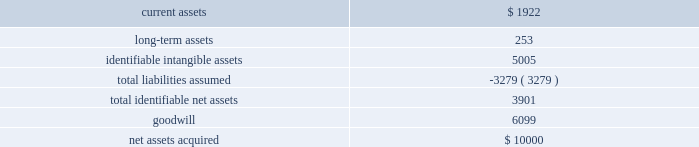58 2016 annual report note 12 .
Business acquisition bayside business solutions , inc .
Effective july 1 , 2015 , the company acquired all of the equity interests of bayside business solutions , an alabama-based company that provides technology solutions and payment processing services primarily for the financial services industry , for $ 10000 paid in cash .
This acquisition was funded using existing operating cash .
The acquisition of bayside business solutions expanded the company 2019s presence in commercial lending within the industry .
Management has completed a purchase price allocation of bayside business solutions and its assessment of the fair value of acquired assets and liabilities assumed .
The recognized amounts of identifiable assets acquired and liabilities assumed , based upon their fair values as of july 1 , 2015 are set forth below: .
The goodwill of $ 6099 arising from this acquisition consists largely of the growth potential , synergies and economies of scale expected from combining the operations of the company with those of bayside business solutions , together with the value of bayside business solutions 2019 assembled workforce .
Goodwill from this acquisition has been allocated to our banking systems and services segment .
The goodwill is not expected to be deductible for income tax purposes .
Identifiable intangible assets from this acquisition consist of customer relationships of $ 3402 , $ 659 of computer software and other intangible assets of $ 944 .
The weighted average amortization period for acquired customer relationships , acquired computer software , and other intangible assets is 15 years , 5 years , and 20 years , respectively .
Current assets were inclusive of cash acquired of $ 1725 .
The fair value of current assets acquired included accounts receivable of $ 178 .
The gross amount of receivables was $ 178 , none of which was expected to be uncollectible .
During fiscal year 2016 , the company incurred $ 55 in costs related to the acquisition of bayside business solutions .
These costs included fees for legal , valuation and other fees .
These costs were included within general and administrative expenses .
The results of bayside business solutions 2019 operations included in the company 2019s consolidated statement of income for the twelve months ended june 30 , 2016 included revenue of $ 4273 and after-tax net income of $ 303 .
The accompanying consolidated statements of income for the fiscal year ended june 30 , 2016 do not include any revenues and expenses related to this acquisition prior to the acquisition date .
The impact of this acquisition was considered immaterial to both the current and prior periods of our consolidated financial statements and pro forma financial information has not been provided .
Banno , llc effective march 1 , 2014 , the company acquired all of the equity interests of banno , an iowa-based company that provides web and transaction marketing services with a focus on the mobile medium , for $ 27910 paid in cash .
This acquisition was funded using existing operating cash .
The acquisition of banno expanded the company 2019s presence in online and mobile technologies within the industry .
During fiscal year 2014 , the company incurred $ 30 in costs related to the acquisition of banno .
These costs included fees for legal , valuation and other fees .
These costs were included within general and administrative expenses .
The results of banno's operations included in the company's consolidated statements of income for the year ended june 30 , 2016 included revenue of $ 6393 and after-tax net loss of $ 1289 .
For the year ended june 30 , 2015 , our consolidated statements of income included revenue of $ 4175 and after-tax net loss of $ 1784 attributable to banno .
The results of banno 2019s operations included in the company 2019s consolidated statement of operations from the acquisition date to june 30 , 2014 included revenue of $ 848 and after-tax net loss of $ 1121 .
The accompanying consolidated statements of income for the twelve month period ended june 30 , 2016 do not include any revenues and expenses related to this acquisition prior to the acquisition date .
The impact of this acquisition was considered immaterial to both the current and prior periods of our consolidated financial statements and pro forma financial information has not been provided. .
Were current assets acquired greater than long-term assets? 
Computations: (1922 > 253)
Answer: yes. 58 2016 annual report note 12 .
Business acquisition bayside business solutions , inc .
Effective july 1 , 2015 , the company acquired all of the equity interests of bayside business solutions , an alabama-based company that provides technology solutions and payment processing services primarily for the financial services industry , for $ 10000 paid in cash .
This acquisition was funded using existing operating cash .
The acquisition of bayside business solutions expanded the company 2019s presence in commercial lending within the industry .
Management has completed a purchase price allocation of bayside business solutions and its assessment of the fair value of acquired assets and liabilities assumed .
The recognized amounts of identifiable assets acquired and liabilities assumed , based upon their fair values as of july 1 , 2015 are set forth below: .
The goodwill of $ 6099 arising from this acquisition consists largely of the growth potential , synergies and economies of scale expected from combining the operations of the company with those of bayside business solutions , together with the value of bayside business solutions 2019 assembled workforce .
Goodwill from this acquisition has been allocated to our banking systems and services segment .
The goodwill is not expected to be deductible for income tax purposes .
Identifiable intangible assets from this acquisition consist of customer relationships of $ 3402 , $ 659 of computer software and other intangible assets of $ 944 .
The weighted average amortization period for acquired customer relationships , acquired computer software , and other intangible assets is 15 years , 5 years , and 20 years , respectively .
Current assets were inclusive of cash acquired of $ 1725 .
The fair value of current assets acquired included accounts receivable of $ 178 .
The gross amount of receivables was $ 178 , none of which was expected to be uncollectible .
During fiscal year 2016 , the company incurred $ 55 in costs related to the acquisition of bayside business solutions .
These costs included fees for legal , valuation and other fees .
These costs were included within general and administrative expenses .
The results of bayside business solutions 2019 operations included in the company 2019s consolidated statement of income for the twelve months ended june 30 , 2016 included revenue of $ 4273 and after-tax net income of $ 303 .
The accompanying consolidated statements of income for the fiscal year ended june 30 , 2016 do not include any revenues and expenses related to this acquisition prior to the acquisition date .
The impact of this acquisition was considered immaterial to both the current and prior periods of our consolidated financial statements and pro forma financial information has not been provided .
Banno , llc effective march 1 , 2014 , the company acquired all of the equity interests of banno , an iowa-based company that provides web and transaction marketing services with a focus on the mobile medium , for $ 27910 paid in cash .
This acquisition was funded using existing operating cash .
The acquisition of banno expanded the company 2019s presence in online and mobile technologies within the industry .
During fiscal year 2014 , the company incurred $ 30 in costs related to the acquisition of banno .
These costs included fees for legal , valuation and other fees .
These costs were included within general and administrative expenses .
The results of banno's operations included in the company's consolidated statements of income for the year ended june 30 , 2016 included revenue of $ 6393 and after-tax net loss of $ 1289 .
For the year ended june 30 , 2015 , our consolidated statements of income included revenue of $ 4175 and after-tax net loss of $ 1784 attributable to banno .
The results of banno 2019s operations included in the company 2019s consolidated statement of operations from the acquisition date to june 30 , 2014 included revenue of $ 848 and after-tax net loss of $ 1121 .
The accompanying consolidated statements of income for the twelve month period ended june 30 , 2016 do not include any revenues and expenses related to this acquisition prior to the acquisition date .
The impact of this acquisition was considered immaterial to both the current and prior periods of our consolidated financial statements and pro forma financial information has not been provided. .
What was the average revenue generated by banno between 2014 and 2016? 
Computations: (848 + (6393 + 4175))
Answer: 11416.0. 59jackhenry.com note 12 .
Business acquisition bayside business solutions , inc .
Effective july 1 , 2015 , the company acquired all of the equity interests of bayside business solutions , an alabama-based company that provides technology solutions and payment processing services primarily for the financial services industry , for $ 10000 paid in cash .
This acquisition was funded using existing operating cash .
The acquisition of bayside business solutions expanded the company 2019s presence in commercial lending within the industry .
Management has completed a purchase price allocation of bayside business solutions and its assessment of the fair value of acquired assets and liabilities assumed .
The recognized amounts of identifiable assets acquired and liabilities assumed , based upon their fair values as of july 1 , 2015 are set forth below: .
The goodwill of $ 6099 arising from this acquisition consists largely of the growth potential , synergies and economies of scale expected from combining the operations of the company with those of bayside business solutions , together with the value of bayside business solutions 2019 assembled workforce .
Goodwill from this acquisition has been allocated to our bank systems and services segment .
The goodwill is not expected to be deductible for income tax purposes .
Identifiable intangible assets from this acquisition consist of customer relationships of $ 3402 , $ 659 of computer software and other intangible assets of $ 944 .
The weighted average amortization period for acquired customer relationships , acquired computer software , and other intangible assets is 15 years , 5 years , and 20 years , respectively .
Current assets were inclusive of cash acquired of $ 1725 .
The fair value of current assets acquired included accounts receivable of $ 178 .
The gross amount of receivables was $ 178 , none of which was expected to be uncollectible .
During fiscal year 2016 , the company incurred $ 55 in costs related to the acquisition of bayside business solutions .
These costs included fees for legal , valuation and other fees .
These costs were included within general and administrative expenses .
The results of bayside business solutions 2019 operations included in the company 2019s consolidated statement of income for the twelve months ended june 30 , 2017 included revenue of $ 6536 and after-tax net income of $ 1307 .
For the twelve months ended june 30 , 2016 , bayside business solutions 2019 contributed $ 4273 to revenue , and after-tax net income of $ 303 .
The accompanying consolidated statements of income do not include any revenues and expenses related to this acquisition prior to the acquisition date .
The impact of this acquisition was considered immaterial to both the current and prior periods of our consolidated financial statements and pro forma financial information has not been provided. .
What was the percent of the total assets acquisitions allocated to goodwill? 
Computations: (6099 / 10000)
Answer: 0.6099. 58 2016 annual report note 12 .
Business acquisition bayside business solutions , inc .
Effective july 1 , 2015 , the company acquired all of the equity interests of bayside business solutions , an alabama-based company that provides technology solutions and payment processing services primarily for the financial services industry , for $ 10000 paid in cash .
This acquisition was funded using existing operating cash .
The acquisition of bayside business solutions expanded the company 2019s presence in commercial lending within the industry .
Management has completed a purchase price allocation of bayside business solutions and its assessment of the fair value of acquired assets and liabilities assumed .
The recognized amounts of identifiable assets acquired and liabilities assumed , based upon their fair values as of july 1 , 2015 are set forth below: .
The goodwill of $ 6099 arising from this acquisition consists largely of the growth potential , synergies and economies of scale expected from combining the operations of the company with those of bayside business solutions , together with the value of bayside business solutions 2019 assembled workforce .
Goodwill from this acquisition has been allocated to our banking systems and services segment .
The goodwill is not expected to be deductible for income tax purposes .
Identifiable intangible assets from this acquisition consist of customer relationships of $ 3402 , $ 659 of computer software and other intangible assets of $ 944 .
The weighted average amortization period for acquired customer relationships , acquired computer software , and other intangible assets is 15 years , 5 years , and 20 years , respectively .
Current assets were inclusive of cash acquired of $ 1725 .
The fair value of current assets acquired included accounts receivable of $ 178 .
The gross amount of receivables was $ 178 , none of which was expected to be uncollectible .
During fiscal year 2016 , the company incurred $ 55 in costs related to the acquisition of bayside business solutions .
These costs included fees for legal , valuation and other fees .
These costs were included within general and administrative expenses .
The results of bayside business solutions 2019 operations included in the company 2019s consolidated statement of income for the twelve months ended june 30 , 2016 included revenue of $ 4273 and after-tax net income of $ 303 .
The accompanying consolidated statements of income for the fiscal year ended june 30 , 2016 do not include any revenues and expenses related to this acquisition prior to the acquisition date .
The impact of this acquisition was considered immaterial to both the current and prior periods of our consolidated financial statements and pro forma financial information has not been provided .
Banno , llc effective march 1 , 2014 , the company acquired all of the equity interests of banno , an iowa-based company that provides web and transaction marketing services with a focus on the mobile medium , for $ 27910 paid in cash .
This acquisition was funded using existing operating cash .
The acquisition of banno expanded the company 2019s presence in online and mobile technologies within the industry .
During fiscal year 2014 , the company incurred $ 30 in costs related to the acquisition of banno .
These costs included fees for legal , valuation and other fees .
These costs were included within general and administrative expenses .
The results of banno's operations included in the company's consolidated statements of income for the year ended june 30 , 2016 included revenue of $ 6393 and after-tax net loss of $ 1289 .
For the year ended june 30 , 2015 , our consolidated statements of income included revenue of $ 4175 and after-tax net loss of $ 1784 attributable to banno .
The results of banno 2019s operations included in the company 2019s consolidated statement of operations from the acquisition date to june 30 , 2014 included revenue of $ 848 and after-tax net loss of $ 1121 .
The accompanying consolidated statements of income for the twelve month period ended june 30 , 2016 do not include any revenues and expenses related to this acquisition prior to the acquisition date .
The impact of this acquisition was considered immaterial to both the current and prior periods of our consolidated financial statements and pro forma financial information has not been provided. .
What was the percent of the ash in the current assets acquired? 
Computations: (1725 / 1922)
Answer: 0.8975. 59jackhenry.com note 12 .
Business acquisition bayside business solutions , inc .
Effective july 1 , 2015 , the company acquired all of the equity interests of bayside business solutions , an alabama-based company that provides technology solutions and payment processing services primarily for the financial services industry , for $ 10000 paid in cash .
This acquisition was funded using existing operating cash .
The acquisition of bayside business solutions expanded the company 2019s presence in commercial lending within the industry .
Management has completed a purchase price allocation of bayside business solutions and its assessment of the fair value of acquired assets and liabilities assumed .
The recognized amounts of identifiable assets acquired and liabilities assumed , based upon their fair values as of july 1 , 2015 are set forth below: .
The goodwill of $ 6099 arising from this acquisition consists largely of the growth potential , synergies and economies of scale expected from combining the operations of the company with those of bayside business solutions , together with the value of bayside business solutions 2019 assembled workforce .
Goodwill from this acquisition has been allocated to our bank systems and services segment .
The goodwill is not expected to be deductible for income tax purposes .
Identifiable intangible assets from this acquisition consist of customer relationships of $ 3402 , $ 659 of computer software and other intangible assets of $ 944 .
The weighted average amortization period for acquired customer relationships , acquired computer software , and other intangible assets is 15 years , 5 years , and 20 years , respectively .
Current assets were inclusive of cash acquired of $ 1725 .
The fair value of current assets acquired included accounts receivable of $ 178 .
The gross amount of receivables was $ 178 , none of which was expected to be uncollectible .
During fiscal year 2016 , the company incurred $ 55 in costs related to the acquisition of bayside business solutions .
These costs included fees for legal , valuation and other fees .
These costs were included within general and administrative expenses .
The results of bayside business solutions 2019 operations included in the company 2019s consolidated statement of income for the twelve months ended june 30 , 2017 included revenue of $ 6536 and after-tax net income of $ 1307 .
For the twelve months ended june 30 , 2016 , bayside business solutions 2019 contributed $ 4273 to revenue , and after-tax net income of $ 303 .
The accompanying consolidated statements of income do not include any revenues and expenses related to this acquisition prior to the acquisition date .
The impact of this acquisition was considered immaterial to both the current and prior periods of our consolidated financial statements and pro forma financial information has not been provided. .
For the identifiable intangible assets from this acquisition , was the computer software greater than the other intangible assets? 
Computations: (659 > 944)
Answer: no. 59jackhenry.com note 12 .
Business acquisition bayside business solutions , inc .
Effective july 1 , 2015 , the company acquired all of the equity interests of bayside business solutions , an alabama-based company that provides technology solutions and payment processing services primarily for the financial services industry , for $ 10000 paid in cash .
This acquisition was funded using existing operating cash .
The acquisition of bayside business solutions expanded the company 2019s presence in commercial lending within the industry .
Management has completed a purchase price allocation of bayside business solutions and its assessment of the fair value of acquired assets and liabilities assumed .
The recognized amounts of identifiable assets acquired and liabilities assumed , based upon their fair values as of july 1 , 2015 are set forth below: .
The goodwill of $ 6099 arising from this acquisition consists largely of the growth potential , synergies and economies of scale expected from combining the operations of the company with those of bayside business solutions , together with the value of bayside business solutions 2019 assembled workforce .
Goodwill from this acquisition has been allocated to our bank systems and services segment .
The goodwill is not expected to be deductible for income tax purposes .
Identifiable intangible assets from this acquisition consist of customer relationships of $ 3402 , $ 659 of computer software and other intangible assets of $ 944 .
The weighted average amortization period for acquired customer relationships , acquired computer software , and other intangible assets is 15 years , 5 years , and 20 years , respectively .
Current assets were inclusive of cash acquired of $ 1725 .
The fair value of current assets acquired included accounts receivable of $ 178 .
The gross amount of receivables was $ 178 , none of which was expected to be uncollectible .
During fiscal year 2016 , the company incurred $ 55 in costs related to the acquisition of bayside business solutions .
These costs included fees for legal , valuation and other fees .
These costs were included within general and administrative expenses .
The results of bayside business solutions 2019 operations included in the company 2019s consolidated statement of income for the twelve months ended june 30 , 2017 included revenue of $ 6536 and after-tax net income of $ 1307 .
For the twelve months ended june 30 , 2016 , bayside business solutions 2019 contributed $ 4273 to revenue , and after-tax net income of $ 303 .
The accompanying consolidated statements of income do not include any revenues and expenses related to this acquisition prior to the acquisition date .
The impact of this acquisition was considered immaterial to both the current and prior periods of our consolidated financial statements and pro forma financial information has not been provided. .
Of the current assets ( inclusive of cash acquired of $ 1725 ) , what percentage was accounts receivable? 
Computations: (178 / 1725)
Answer: 0.10319. 58 2016 annual report note 12 .
Business acquisition bayside business solutions , inc .
Effective july 1 , 2015 , the company acquired all of the equity interests of bayside business solutions , an alabama-based company that provides technology solutions and payment processing services primarily for the financial services industry , for $ 10000 paid in cash .
This acquisition was funded using existing operating cash .
The acquisition of bayside business solutions expanded the company 2019s presence in commercial lending within the industry .
Management has completed a purchase price allocation of bayside business solutions and its assessment of the fair value of acquired assets and liabilities assumed .
The recognized amounts of identifiable assets acquired and liabilities assumed , based upon their fair values as of july 1 , 2015 are set forth below: .
The goodwill of $ 6099 arising from this acquisition consists largely of the growth potential , synergies and economies of scale expected from combining the operations of the company with those of bayside business solutions , together with the value of bayside business solutions 2019 assembled workforce .
Goodwill from this acquisition has been allocated to our banking systems and services segment .
The goodwill is not expected to be deductible for income tax purposes .
Identifiable intangible assets from this acquisition consist of customer relationships of $ 3402 , $ 659 of computer software and other intangible assets of $ 944 .
The weighted average amortization period for acquired customer relationships , acquired computer software , and other intangible assets is 15 years , 5 years , and 20 years , respectively .
Current assets were inclusive of cash acquired of $ 1725 .
The fair value of current assets acquired included accounts receivable of $ 178 .
The gross amount of receivables was $ 178 , none of which was expected to be uncollectible .
During fiscal year 2016 , the company incurred $ 55 in costs related to the acquisition of bayside business solutions .
These costs included fees for legal , valuation and other fees .
These costs were included within general and administrative expenses .
The results of bayside business solutions 2019 operations included in the company 2019s consolidated statement of income for the twelve months ended june 30 , 2016 included revenue of $ 4273 and after-tax net income of $ 303 .
The accompanying consolidated statements of income for the fiscal year ended june 30 , 2016 do not include any revenues and expenses related to this acquisition prior to the acquisition date .
The impact of this acquisition was considered immaterial to both the current and prior periods of our consolidated financial statements and pro forma financial information has not been provided .
Banno , llc effective march 1 , 2014 , the company acquired all of the equity interests of banno , an iowa-based company that provides web and transaction marketing services with a focus on the mobile medium , for $ 27910 paid in cash .
This acquisition was funded using existing operating cash .
The acquisition of banno expanded the company 2019s presence in online and mobile technologies within the industry .
During fiscal year 2014 , the company incurred $ 30 in costs related to the acquisition of banno .
These costs included fees for legal , valuation and other fees .
These costs were included within general and administrative expenses .
The results of banno's operations included in the company's consolidated statements of income for the year ended june 30 , 2016 included revenue of $ 6393 and after-tax net loss of $ 1289 .
For the year ended june 30 , 2015 , our consolidated statements of income included revenue of $ 4175 and after-tax net loss of $ 1784 attributable to banno .
The results of banno 2019s operations included in the company 2019s consolidated statement of operations from the acquisition date to june 30 , 2014 included revenue of $ 848 and after-tax net loss of $ 1121 .
The accompanying consolidated statements of income for the twelve month period ended june 30 , 2016 do not include any revenues and expenses related to this acquisition prior to the acquisition date .
The impact of this acquisition was considered immaterial to both the current and prior periods of our consolidated financial statements and pro forma financial information has not been provided. .
What was the percent of the make-up of the acquisition that was allocated to the goodwill in the net assets acquired? 
Computations: (6099 / 10000)
Answer: 0.6099. 